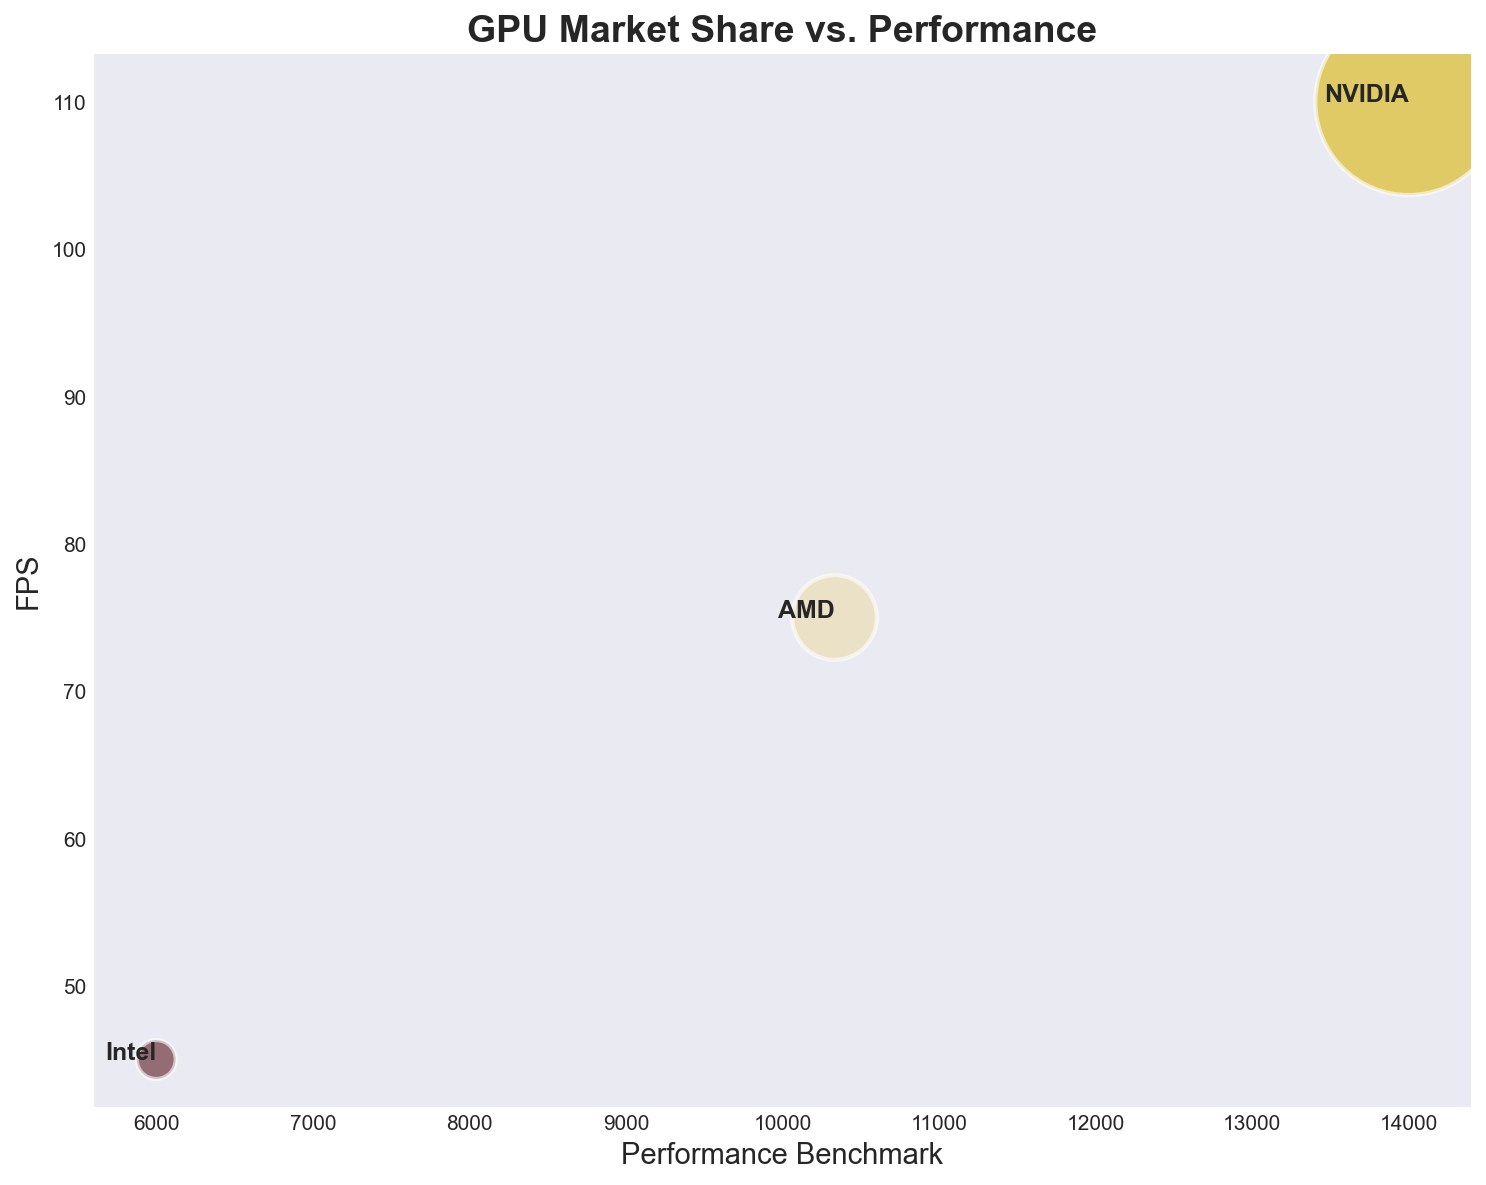Which manufacturer has the largest market share? The figure shows bubble sizes proportional to the market share of each manufacturer. The largest bubble represents the manufacturer with the largest market share.
Answer: NVIDIA What's the average FPS for all manufacturers combined? First, observe the FPS values of all manufacturers: NVIDIA (110 FPS), AMD (75 FPS), Intel (45 FPS). Then, calculate the average: (110 + 75 + 45) / 3 = 230 / 3 = 76.67
Answer: 76.67 Which manufacturer has the brightest color bubble? The colors aren't specified in detail, but to answer this question, visually compare the bubbles and identify the one with the most luminance.
Answer: Answer depends on the specific rendering but often appears subjective Between AMD and Intel, which manufacturer has a higher Performance Benchmark? Compare the Performance Benchmark values for AMD (10000) and Intel (6000) from the figure. AMD's value is higher.
Answer: AMD What is the total market share for all manufacturers? Sum the market shares for NVIDIA (80), AMD (16), and Intel (4). 80 + 16 + 4 = 100
Answer: 100 If we add 10 FPS to each manufacturer's average FPS, what would be the new average FPS for NVIDIA? NVIDIA's current FPS is 110. Adding 10 gives 110 + 10 = 120. The new average is 120
Answer: 120 Which manufacturer has the smallest bubble? The smallest bubble represents the smallest market share, which corresponds to Intel based on the data provided.
Answer: Intel Which manufacturer has the highest average FPS? Compare the FPS values of NVIDIA (110 FPS), AMD (75 FPS), Intel (45 FPS). NVIDIA has the highest FPS.
Answer: NVIDIA Does any manufacturer have both the highest market share and the highest performance benchmark? Identify the manufacturer with the highest market share (NVIDIA, 80) and compare it to the highest performance benchmark (NVIDIA, 14000). Since both belong to NVIDIA, the answer is yes.
Answer: Yes Compare the FPS increase from Intel to AMD and AMD to NVIDIA, and determine which increase is larger. Calculate the FPS increases: From Intel (45) to AMD (75), the increase is 75 - 45 = 30. From AMD (75) to NVIDIA (110), the increase is 110 - 75 = 35. The increase from AMD to NVIDIA is larger.
Answer: AMD to NVIDIA 